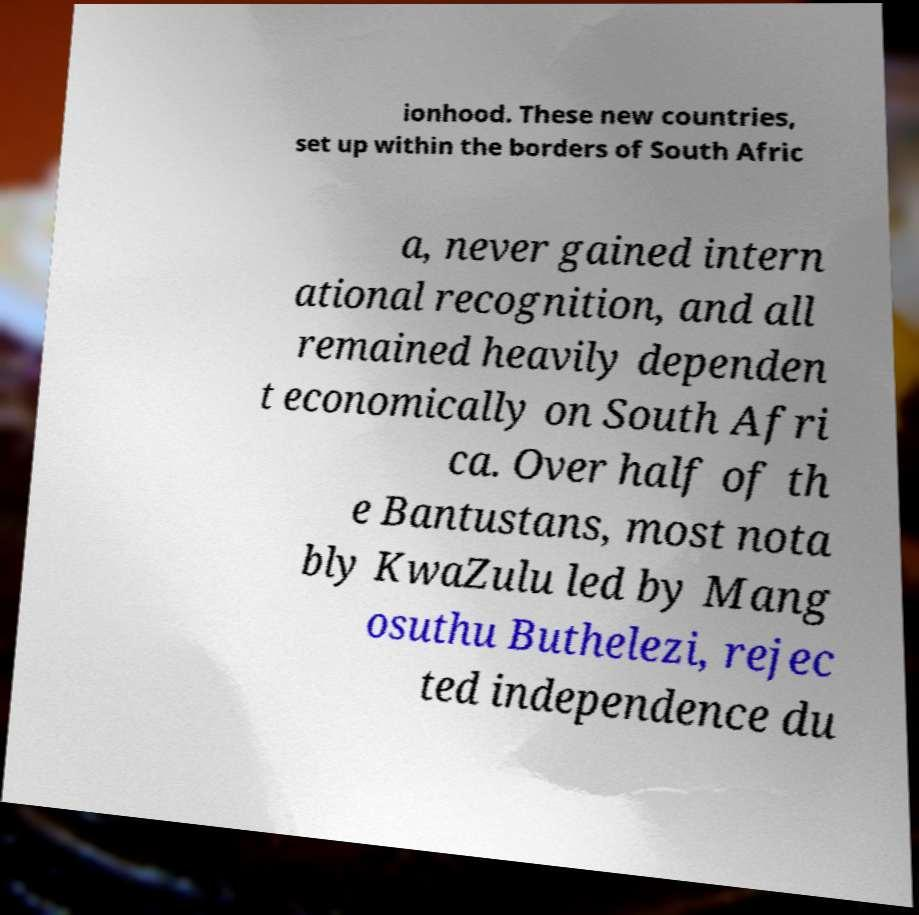I need the written content from this picture converted into text. Can you do that? ionhood. These new countries, set up within the borders of South Afric a, never gained intern ational recognition, and all remained heavily dependen t economically on South Afri ca. Over half of th e Bantustans, most nota bly KwaZulu led by Mang osuthu Buthelezi, rejec ted independence du 